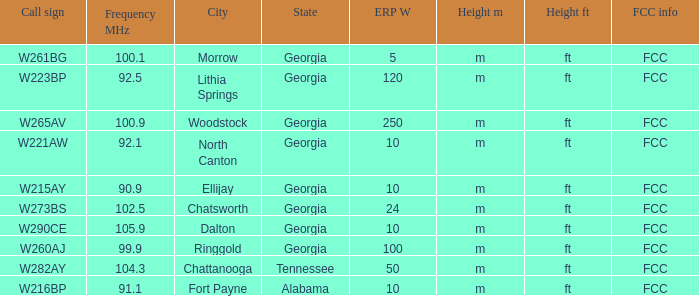Which City of license has a Frequency MHz smaller than 100.9, and a ERP W larger than 100? Lithia Springs, Georgia. 